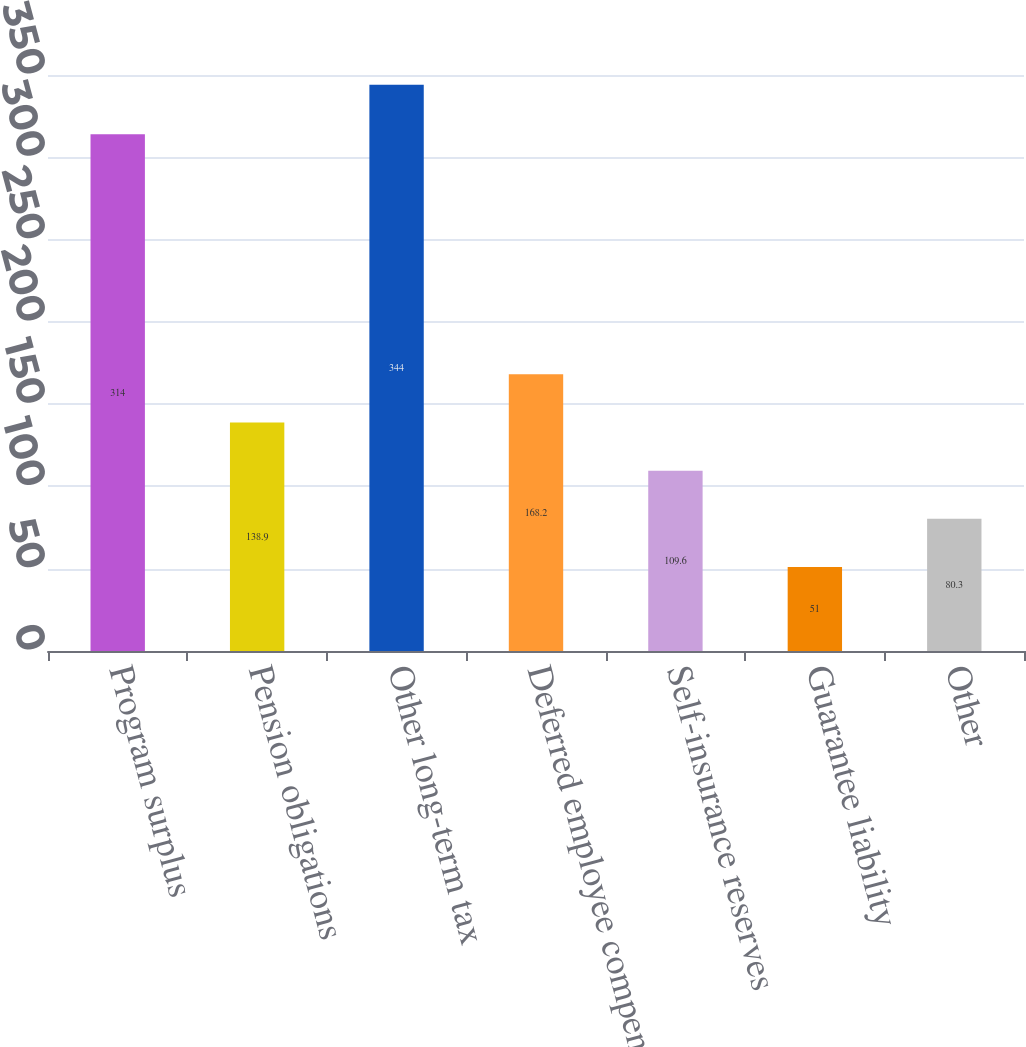Convert chart to OTSL. <chart><loc_0><loc_0><loc_500><loc_500><bar_chart><fcel>Program surplus<fcel>Pension obligations<fcel>Other long-term tax<fcel>Deferred employee compensation<fcel>Self-insurance reserves<fcel>Guarantee liability<fcel>Other<nl><fcel>314<fcel>138.9<fcel>344<fcel>168.2<fcel>109.6<fcel>51<fcel>80.3<nl></chart> 